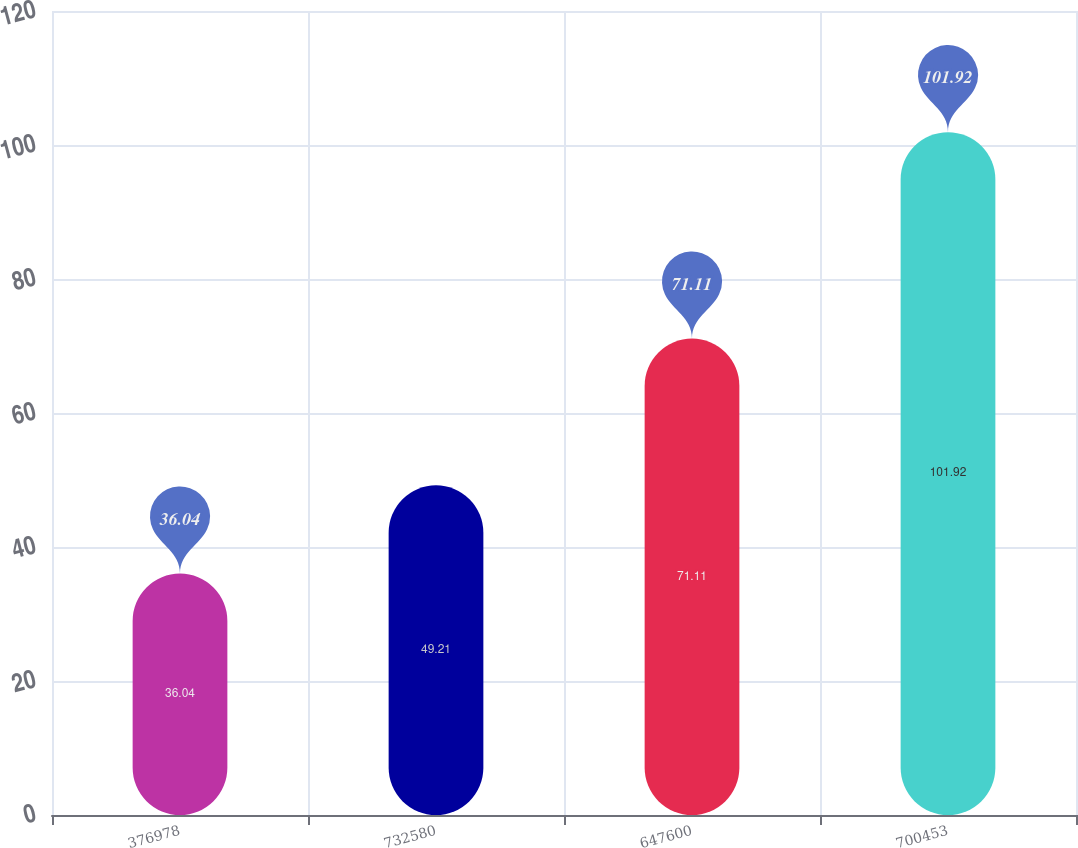<chart> <loc_0><loc_0><loc_500><loc_500><bar_chart><fcel>376978<fcel>732580<fcel>647600<fcel>700453<nl><fcel>36.04<fcel>49.21<fcel>71.11<fcel>101.92<nl></chart> 